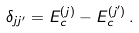Convert formula to latex. <formula><loc_0><loc_0><loc_500><loc_500>\delta _ { j j ^ { \prime } } = E _ { c } ^ { ( j ) } - E _ { c } ^ { ( j ^ { \prime } ) } \, .</formula> 